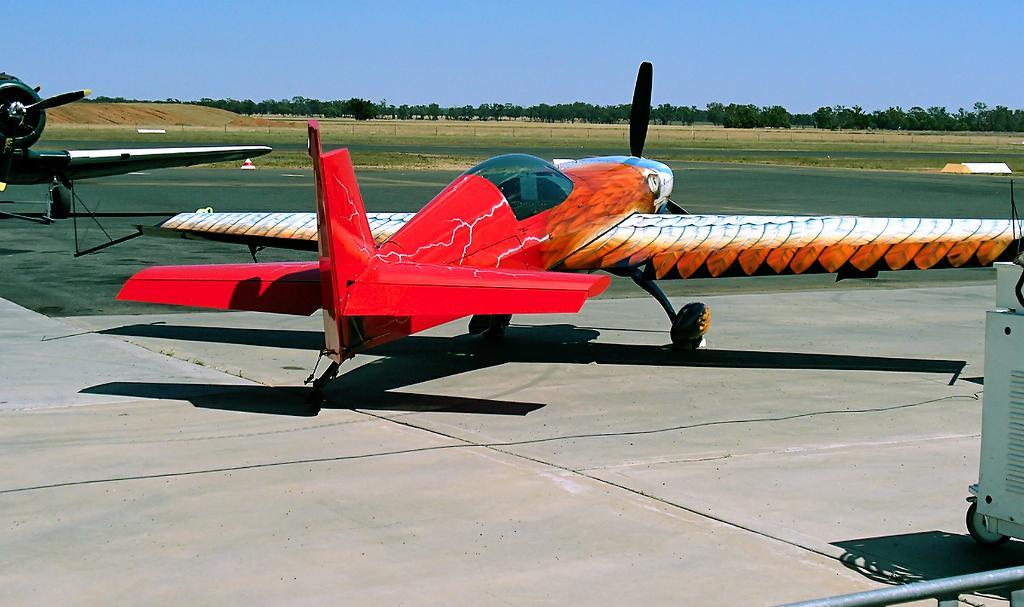What is the main subject of the image? The main subject of the image is airplanes. What can be seen in the background of the image? There is a sky visible in the image, and trees are at the top of the image. What object is located on the right side of the image? There is a machine on the right side of the image. What type of insurance policy is being discussed by the airplanes in the image? There is no indication in the image that the airplanes are discussing any insurance policies. Can you tell me how many cushions are present in the image? There are no cushions present in the image. 